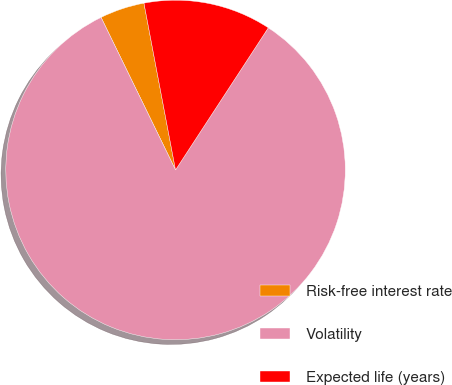<chart> <loc_0><loc_0><loc_500><loc_500><pie_chart><fcel>Risk-free interest rate<fcel>Volatility<fcel>Expected life (years)<nl><fcel>4.25%<fcel>83.56%<fcel>12.18%<nl></chart> 